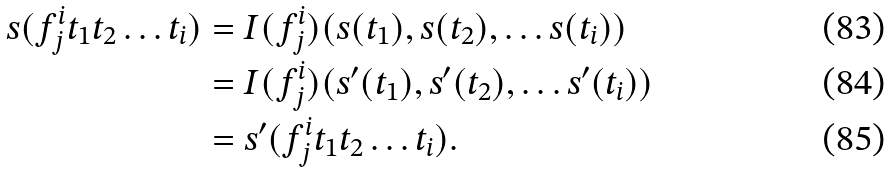<formula> <loc_0><loc_0><loc_500><loc_500>s ( f ^ { i } _ { j } t _ { 1 } t _ { 2 } \dots t _ { i } ) & = I ( f ^ { i } _ { j } ) ( s ( t _ { 1 } ) , s ( t _ { 2 } ) , \dots s ( t _ { i } ) ) \\ & = I ( f ^ { i } _ { j } ) ( s ^ { \prime } ( t _ { 1 } ) , s ^ { \prime } ( t _ { 2 } ) , \dots s ^ { \prime } ( t _ { i } ) ) \\ & = s ^ { \prime } ( f ^ { i } _ { j } t _ { 1 } t _ { 2 } \dots t _ { i } ) .</formula> 